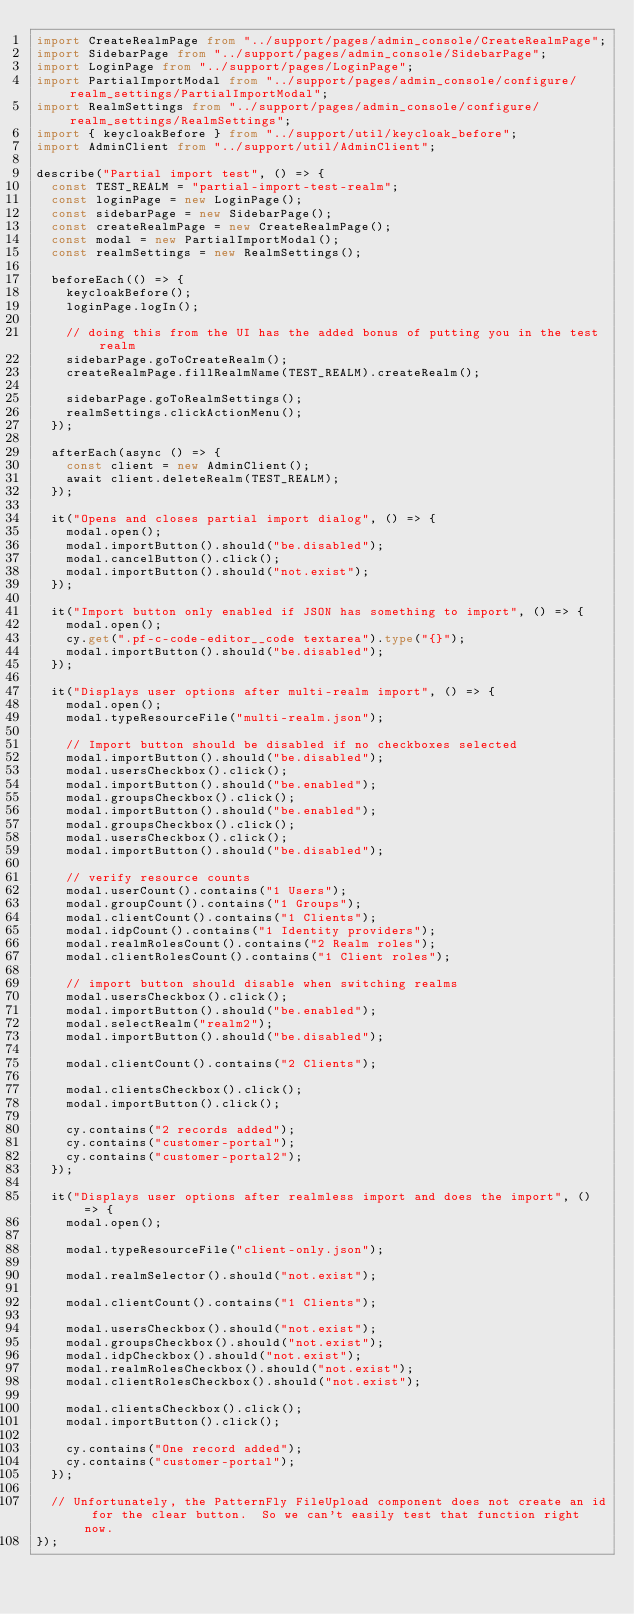Convert code to text. <code><loc_0><loc_0><loc_500><loc_500><_TypeScript_>import CreateRealmPage from "../support/pages/admin_console/CreateRealmPage";
import SidebarPage from "../support/pages/admin_console/SidebarPage";
import LoginPage from "../support/pages/LoginPage";
import PartialImportModal from "../support/pages/admin_console/configure/realm_settings/PartialImportModal";
import RealmSettings from "../support/pages/admin_console/configure/realm_settings/RealmSettings";
import { keycloakBefore } from "../support/util/keycloak_before";
import AdminClient from "../support/util/AdminClient";

describe("Partial import test", () => {
  const TEST_REALM = "partial-import-test-realm";
  const loginPage = new LoginPage();
  const sidebarPage = new SidebarPage();
  const createRealmPage = new CreateRealmPage();
  const modal = new PartialImportModal();
  const realmSettings = new RealmSettings();

  beforeEach(() => {
    keycloakBefore();
    loginPage.logIn();

    // doing this from the UI has the added bonus of putting you in the test realm
    sidebarPage.goToCreateRealm();
    createRealmPage.fillRealmName(TEST_REALM).createRealm();

    sidebarPage.goToRealmSettings();
    realmSettings.clickActionMenu();
  });

  afterEach(async () => {
    const client = new AdminClient();
    await client.deleteRealm(TEST_REALM);
  });

  it("Opens and closes partial import dialog", () => {
    modal.open();
    modal.importButton().should("be.disabled");
    modal.cancelButton().click();
    modal.importButton().should("not.exist");
  });

  it("Import button only enabled if JSON has something to import", () => {
    modal.open();
    cy.get(".pf-c-code-editor__code textarea").type("{}");
    modal.importButton().should("be.disabled");
  });

  it("Displays user options after multi-realm import", () => {
    modal.open();
    modal.typeResourceFile("multi-realm.json");

    // Import button should be disabled if no checkboxes selected
    modal.importButton().should("be.disabled");
    modal.usersCheckbox().click();
    modal.importButton().should("be.enabled");
    modal.groupsCheckbox().click();
    modal.importButton().should("be.enabled");
    modal.groupsCheckbox().click();
    modal.usersCheckbox().click();
    modal.importButton().should("be.disabled");

    // verify resource counts
    modal.userCount().contains("1 Users");
    modal.groupCount().contains("1 Groups");
    modal.clientCount().contains("1 Clients");
    modal.idpCount().contains("1 Identity providers");
    modal.realmRolesCount().contains("2 Realm roles");
    modal.clientRolesCount().contains("1 Client roles");

    // import button should disable when switching realms
    modal.usersCheckbox().click();
    modal.importButton().should("be.enabled");
    modal.selectRealm("realm2");
    modal.importButton().should("be.disabled");

    modal.clientCount().contains("2 Clients");

    modal.clientsCheckbox().click();
    modal.importButton().click();

    cy.contains("2 records added");
    cy.contains("customer-portal");
    cy.contains("customer-portal2");
  });

  it("Displays user options after realmless import and does the import", () => {
    modal.open();

    modal.typeResourceFile("client-only.json");

    modal.realmSelector().should("not.exist");

    modal.clientCount().contains("1 Clients");

    modal.usersCheckbox().should("not.exist");
    modal.groupsCheckbox().should("not.exist");
    modal.idpCheckbox().should("not.exist");
    modal.realmRolesCheckbox().should("not.exist");
    modal.clientRolesCheckbox().should("not.exist");

    modal.clientsCheckbox().click();
    modal.importButton().click();

    cy.contains("One record added");
    cy.contains("customer-portal");
  });

  // Unfortunately, the PatternFly FileUpload component does not create an id for the clear button.  So we can't easily test that function right now.
});
</code> 